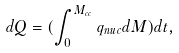Convert formula to latex. <formula><loc_0><loc_0><loc_500><loc_500>d Q = ( \int _ { 0 } ^ { M _ { c c } } q _ { n u c } d M ) d t ,</formula> 